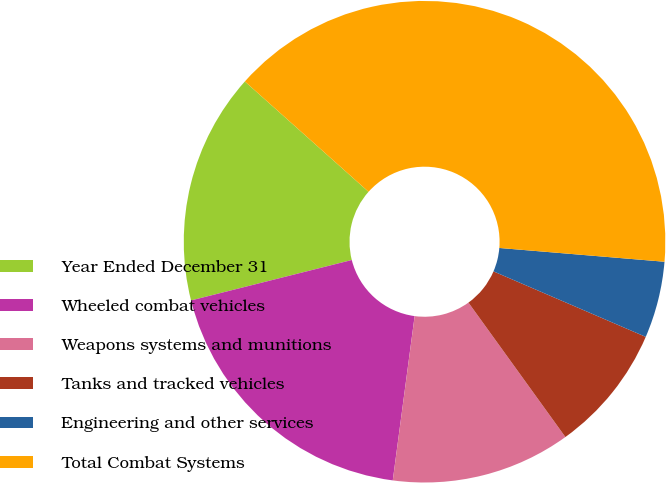Convert chart to OTSL. <chart><loc_0><loc_0><loc_500><loc_500><pie_chart><fcel>Year Ended December 31<fcel>Wheeled combat vehicles<fcel>Weapons systems and munitions<fcel>Tanks and tracked vehicles<fcel>Engineering and other services<fcel>Total Combat Systems<nl><fcel>15.51%<fcel>18.97%<fcel>12.05%<fcel>8.59%<fcel>5.14%<fcel>39.73%<nl></chart> 